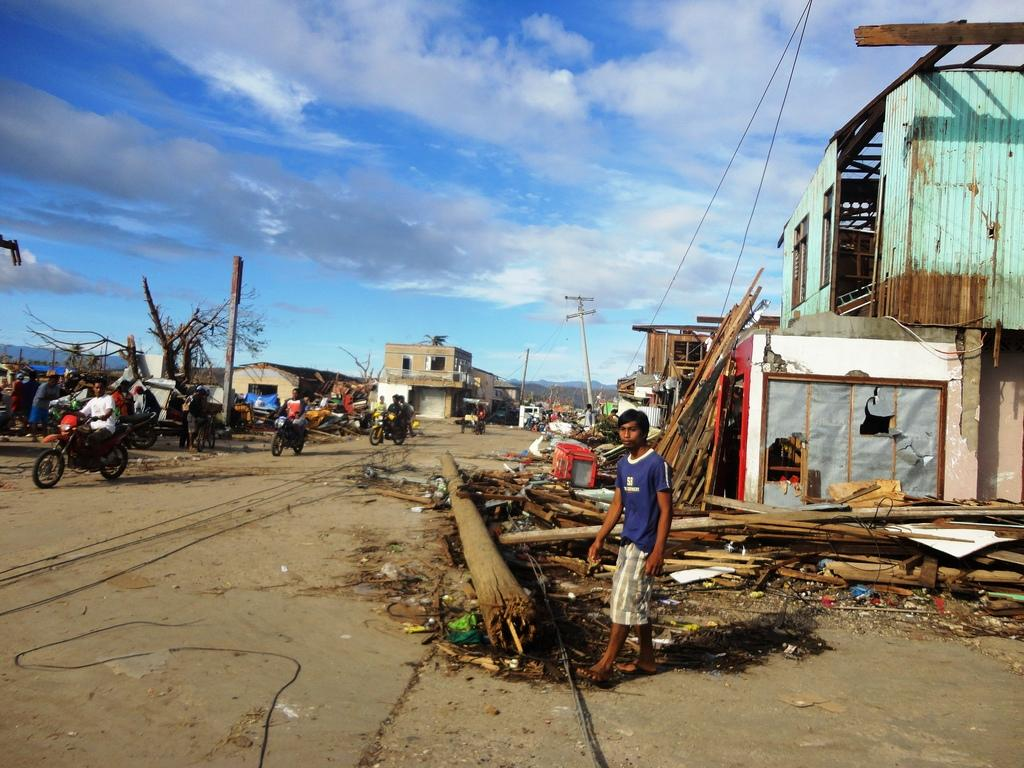What can be seen on the road in the image? There are vehicles on the road in the image. What else is present in the image besides the vehicles? There is a group of people, buildings, trees, poles, and the sky is visible in the background. Can you describe the group of people in the image? The group of people in the image is not specified, but they are present. What type of structures can be seen in the image? Buildings are present in the image. Where are the frogs resting in the image? There are no frogs present in the image. What type of vest is being worn by the person in the image? There is no person or vest visible in the image. 